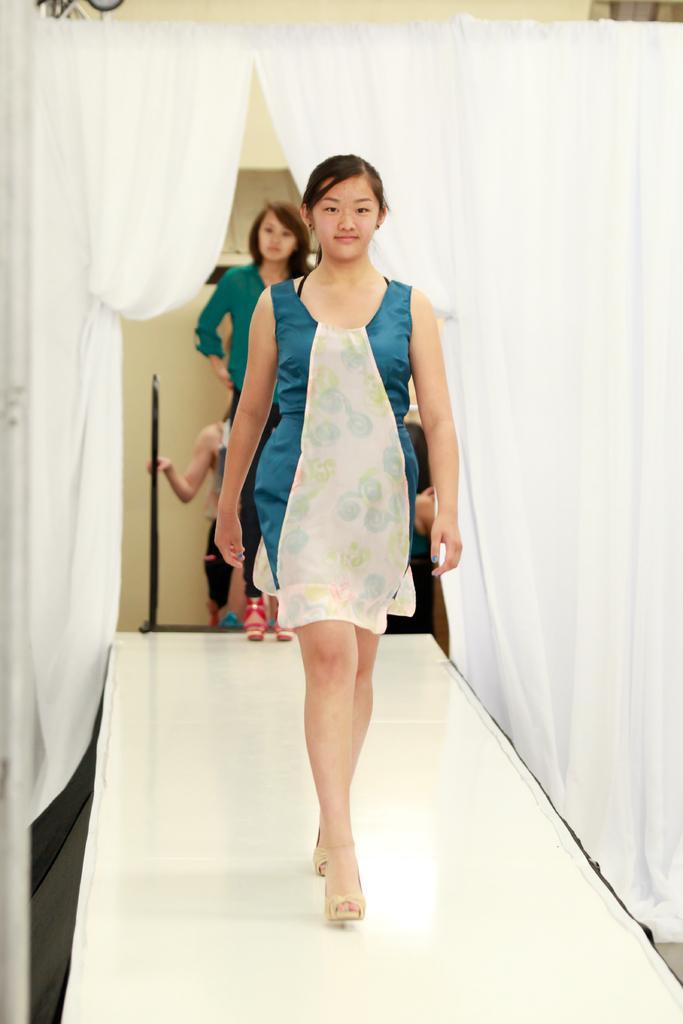How would you summarize this image in a sentence or two? In the center of the image, we can see a lady walking on the ramp and in the background, there are some other people and we can see a rod, a curtain, some stands and there is a wall. 